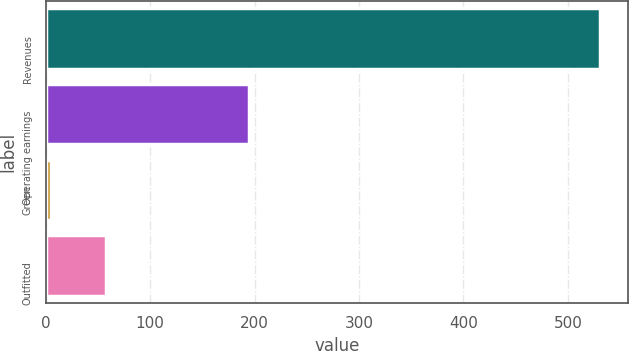Convert chart to OTSL. <chart><loc_0><loc_0><loc_500><loc_500><bar_chart><fcel>Revenues<fcel>Operating earnings<fcel>Green<fcel>Outfitted<nl><fcel>531<fcel>195<fcel>5<fcel>57.6<nl></chart> 